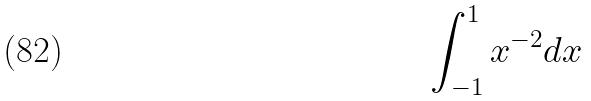Convert formula to latex. <formula><loc_0><loc_0><loc_500><loc_500>\int _ { - 1 } ^ { 1 } x ^ { - 2 } d x</formula> 